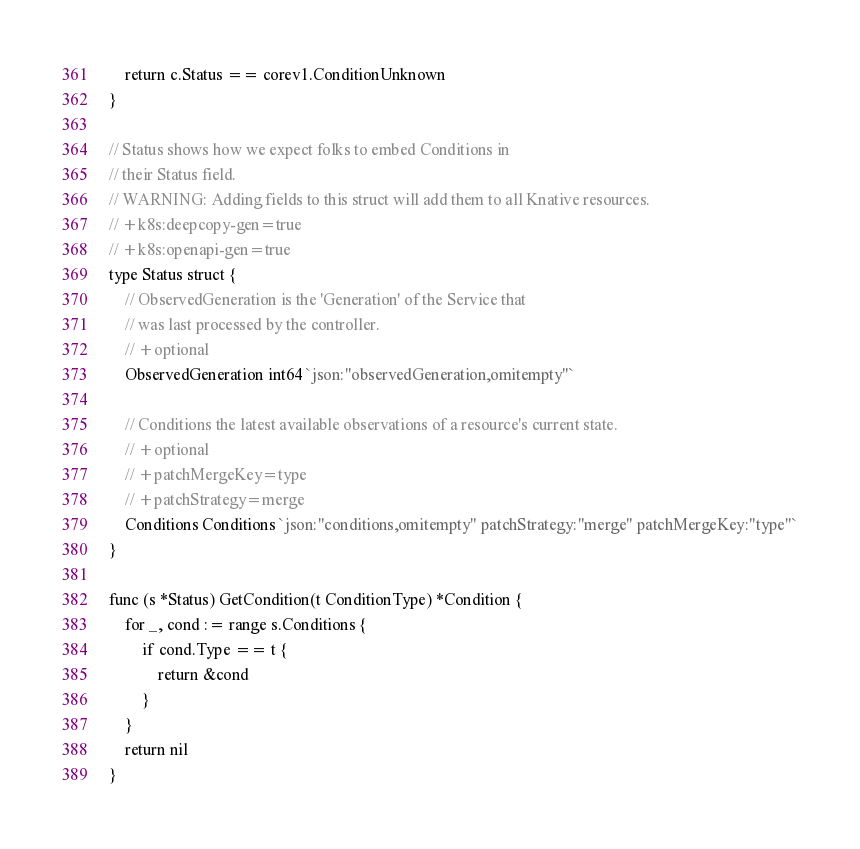<code> <loc_0><loc_0><loc_500><loc_500><_Go_>	return c.Status == corev1.ConditionUnknown
}

// Status shows how we expect folks to embed Conditions in
// their Status field.
// WARNING: Adding fields to this struct will add them to all Knative resources.
// +k8s:deepcopy-gen=true
// +k8s:openapi-gen=true
type Status struct {
	// ObservedGeneration is the 'Generation' of the Service that
	// was last processed by the controller.
	// +optional
	ObservedGeneration int64 `json:"observedGeneration,omitempty"`

	// Conditions the latest available observations of a resource's current state.
	// +optional
	// +patchMergeKey=type
	// +patchStrategy=merge
	Conditions Conditions `json:"conditions,omitempty" patchStrategy:"merge" patchMergeKey:"type"`
}

func (s *Status) GetCondition(t ConditionType) *Condition {
	for _, cond := range s.Conditions {
		if cond.Type == t {
			return &cond
		}
	}
	return nil
}
</code> 